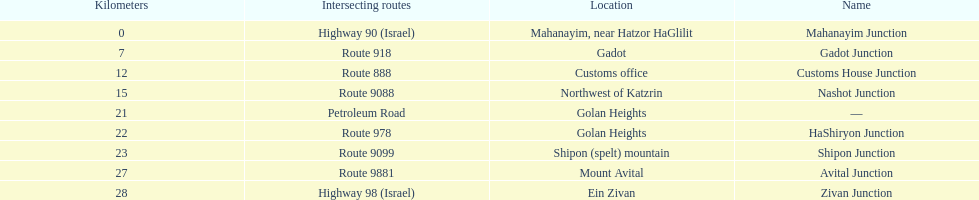What junction is the furthest from mahanayim junction? Zivan Junction. 